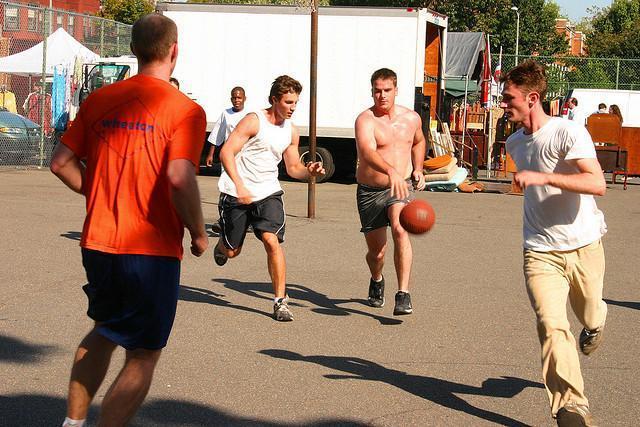How many people are there?
Give a very brief answer. 4. 